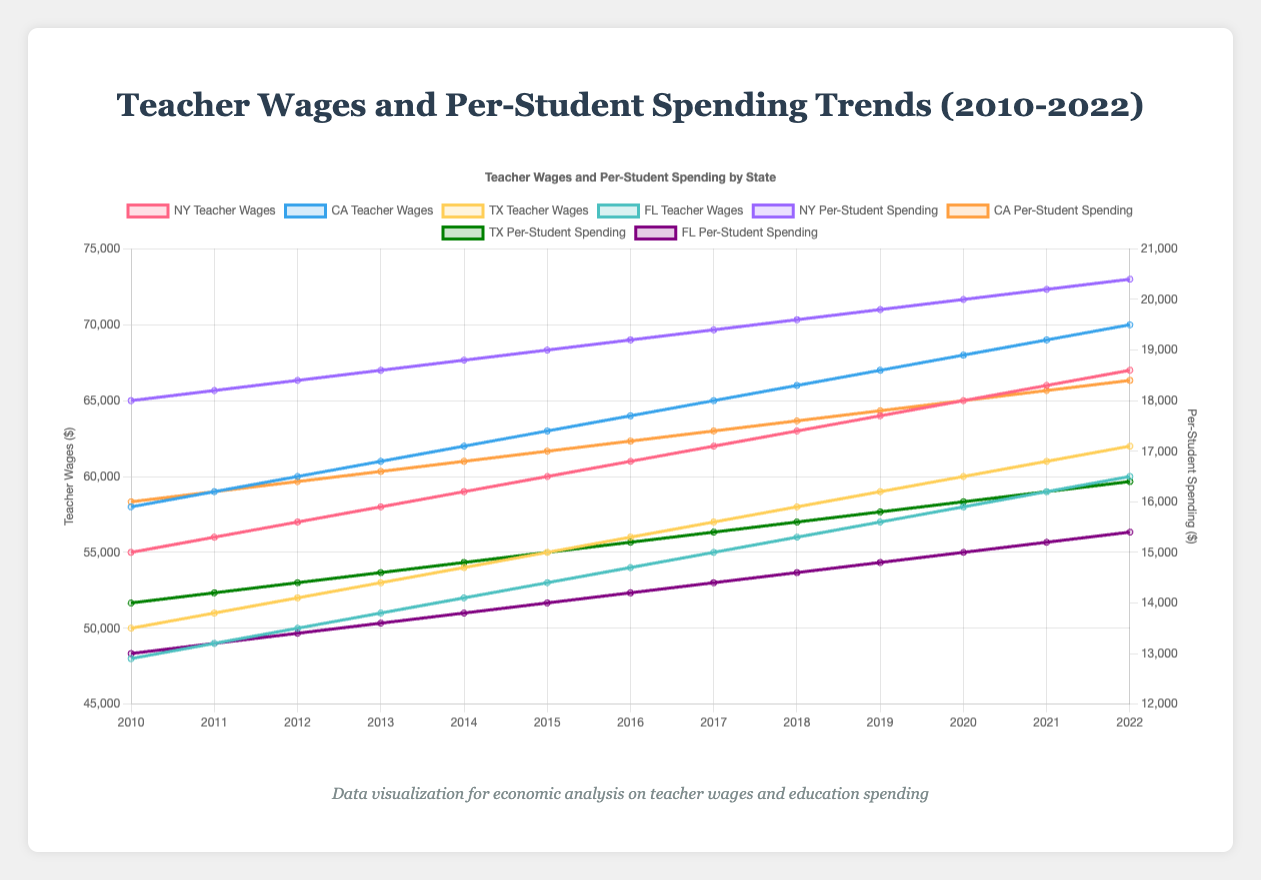What is the difference in teacher wages between New York and Florida in 2022? To find the difference, locate the teacher wages for New York and Florida in 2022. New York's teacher wage in 2022 is $67,000 and Florida's is $60,000. Subtract Florida's wage from New York's: $67,000 - $60,000 = $7,000
Answer: $7,000 Which state had the highest per-student spending in 2022? Look at the per-student spending values for 2022 across all states. New York has the highest per-student spending at $20,400.
Answer: New York How much did teacher wages in California increase from 2010 to 2022? Find California's teacher wages in 2010 and 2022. In 2010, it was $58,000, and in 2022, it was $70,000. The increase is $70,000 - $58,000 = $12,000.
Answer: $12,000 Which state had the smallest increase in per-student spending from 2010 to 2022? Calculate the increase for each state by subtracting 2010 values from 2022 values: 
- New York: $20,400 - $18,000 = $2,400
- California: $18,400 - $16,000 = $2,400
- Texas: $16,400 - $14,000 = $2,400
- Florida: $15,400 - $13,000 = $2,400
Florida has the smallest increase.
Answer: Florida Compare the trend of teacher wages and per-student spending in New York. Do they increase at the same rate? Observe the slopes of the lines for New York's teacher wages and per-student spending. Teacher wages increased from $55,000 to $67,000 (an increase of $12,000), while per-student spending increased from $18,000 to $20,400 (an increase of $2,400). The teacher wages are increasing at a higher rate than per-student spending.
Answer: No What is the average teacher wage in Florida over the given years? Calculate the average by summing Florida's teacher wages from 2010 to 2022 and dividing by the number of years: (48000 + 49000 + 50000 + 51000 + 52000 + 53000 + 54000 + 55000 + 56000 + 57000 + 58000 + 59000 + 60000) / 13 = 535000 / 13 = 41,153.85
Answer: $52,000 Did any state's per-student spending surpass California's teacher wages in 2022? Compare the per-student spending for each state with California's teacher wage of $70,000 in 2022. None of the states' per-student spending values surpass $70,000.
Answer: No Between New York and Texas, which state had a greater increase in teacher wages over the years? Calculate the increase in teacher wages for both states from 2010 to 2022:
- New York: $67,000 - $55,000 = $12,000
- Texas: $62,000 - $50,000 = $12,000
Both states had the same increase in teacher wages.
Answer: Neither, both are equal at $12,000 By how much did Florida's per-student spending increase from 2010 to 2015? Find Florida's spending in 2010 and 2015: $13,000 in 2010 and $14,000 in 2015. Calculate the difference: $14,000 - $13,000 = $1,000.
Answer: $1,000 